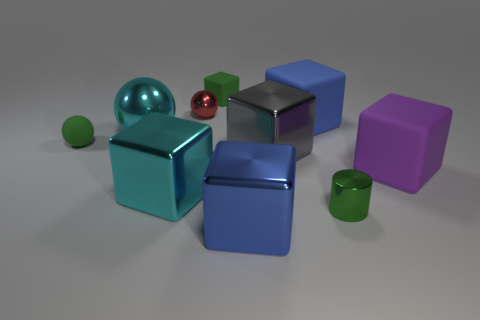Is the number of gray cubes that are left of the cyan metal block less than the number of small green objects that are to the right of the blue metallic cube?
Offer a terse response. Yes. How many cubes are gray metal objects or big blue metallic objects?
Keep it short and to the point. 2. Is the material of the tiny thing that is on the left side of the small red shiny ball the same as the big cyan object in front of the big purple rubber block?
Give a very brief answer. No. There is a purple object that is the same size as the gray metallic thing; what is its shape?
Your answer should be very brief. Cube. What number of other things are there of the same color as the metallic cylinder?
Your response must be concise. 2. What number of brown objects are big things or big spheres?
Your response must be concise. 0. Do the large blue object on the right side of the big blue metallic object and the small rubber thing that is to the left of the cyan metallic cube have the same shape?
Your answer should be very brief. No. How many other things are made of the same material as the green cylinder?
Provide a succinct answer. 5. Is there a matte sphere left of the small matte thing in front of the tiny matte object to the right of the cyan sphere?
Offer a terse response. No. Is the material of the big purple object the same as the small green cylinder?
Keep it short and to the point. No. 